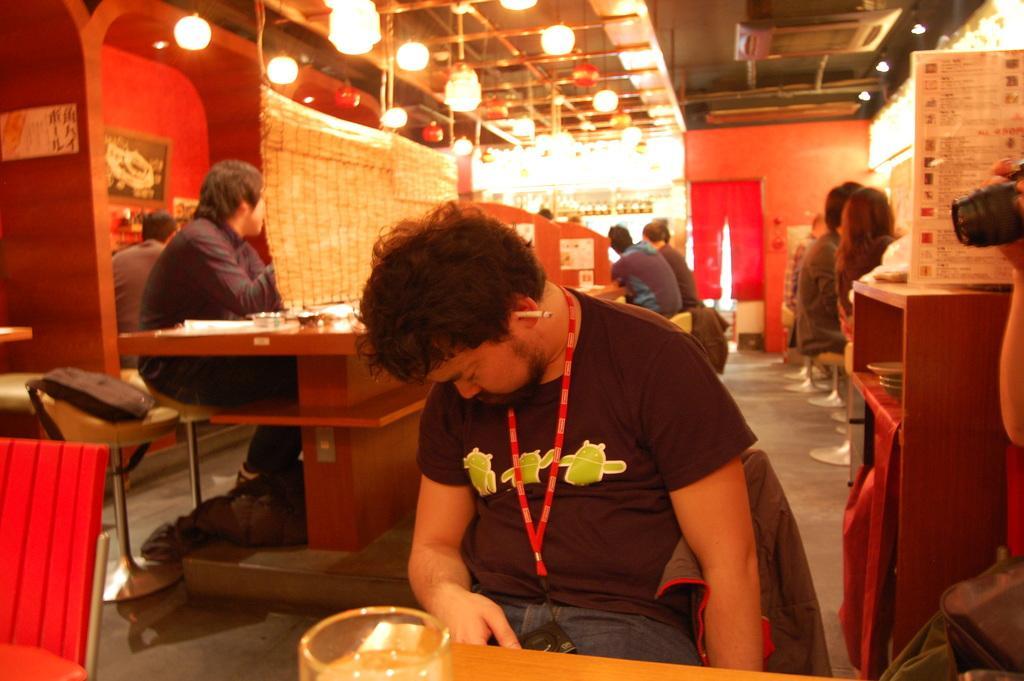Describe this image in one or two sentences. Here we can see a person sitting on the chair, and in front there is the table, and at back there are group of people sitting,and at top there are lights. 